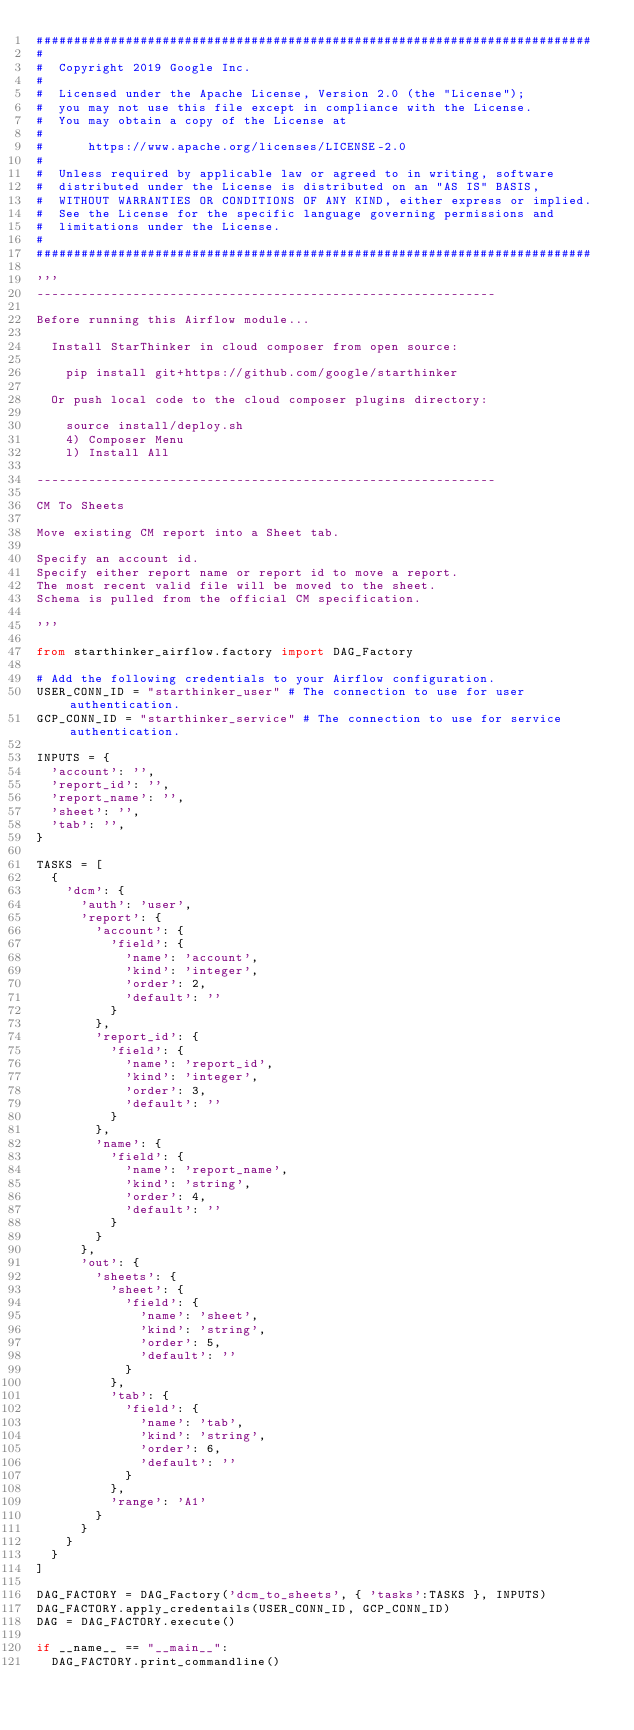Convert code to text. <code><loc_0><loc_0><loc_500><loc_500><_Python_>###########################################################################
# 
#  Copyright 2019 Google Inc.
#
#  Licensed under the Apache License, Version 2.0 (the "License");
#  you may not use this file except in compliance with the License.
#  You may obtain a copy of the License at
#
#      https://www.apache.org/licenses/LICENSE-2.0
#
#  Unless required by applicable law or agreed to in writing, software
#  distributed under the License is distributed on an "AS IS" BASIS,
#  WITHOUT WARRANTIES OR CONDITIONS OF ANY KIND, either express or implied.
#  See the License for the specific language governing permissions and
#  limitations under the License.
#
###########################################################################

'''
--------------------------------------------------------------

Before running this Airflow module...

  Install StarThinker in cloud composer from open source: 

    pip install git+https://github.com/google/starthinker

  Or push local code to the cloud composer plugins directory:

    source install/deploy.sh
    4) Composer Menu	   
    l) Install All

--------------------------------------------------------------

CM To Sheets

Move existing CM report into a Sheet tab.

Specify an account id.
Specify either report name or report id to move a report.
The most recent valid file will be moved to the sheet.
Schema is pulled from the official CM specification.

'''

from starthinker_airflow.factory import DAG_Factory
 
# Add the following credentials to your Airflow configuration.
USER_CONN_ID = "starthinker_user" # The connection to use for user authentication.
GCP_CONN_ID = "starthinker_service" # The connection to use for service authentication.

INPUTS = {
  'account': '',
  'report_id': '',
  'report_name': '',
  'sheet': '',
  'tab': '',
}

TASKS = [
  {
    'dcm': {
      'auth': 'user',
      'report': {
        'account': {
          'field': {
            'name': 'account',
            'kind': 'integer',
            'order': 2,
            'default': ''
          }
        },
        'report_id': {
          'field': {
            'name': 'report_id',
            'kind': 'integer',
            'order': 3,
            'default': ''
          }
        },
        'name': {
          'field': {
            'name': 'report_name',
            'kind': 'string',
            'order': 4,
            'default': ''
          }
        }
      },
      'out': {
        'sheets': {
          'sheet': {
            'field': {
              'name': 'sheet',
              'kind': 'string',
              'order': 5,
              'default': ''
            }
          },
          'tab': {
            'field': {
              'name': 'tab',
              'kind': 'string',
              'order': 6,
              'default': ''
            }
          },
          'range': 'A1'
        }
      }
    }
  }
]

DAG_FACTORY = DAG_Factory('dcm_to_sheets', { 'tasks':TASKS }, INPUTS)
DAG_FACTORY.apply_credentails(USER_CONN_ID, GCP_CONN_ID)
DAG = DAG_FACTORY.execute()

if __name__ == "__main__":
  DAG_FACTORY.print_commandline()
</code> 